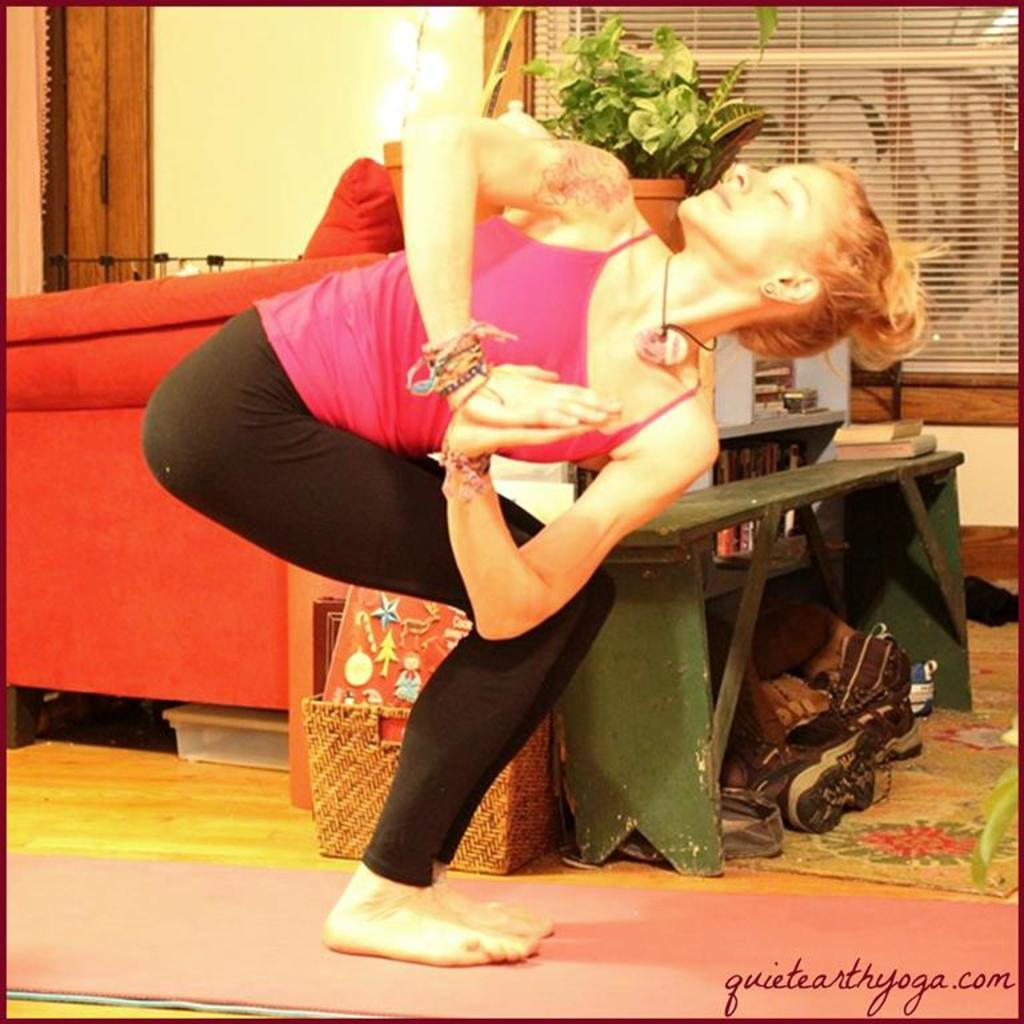Who is present in the image? There is a woman in the image. What is the woman wearing? The woman is wearing a pink dress. What objects can be seen in the image? There is a basket and a book in the image. What is the background of the image? There is a wall in the image. What time of day is it during the class in the image? There is no class or indication of time of day in the image. 